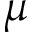Convert formula to latex. <formula><loc_0><loc_0><loc_500><loc_500>\mu</formula> 